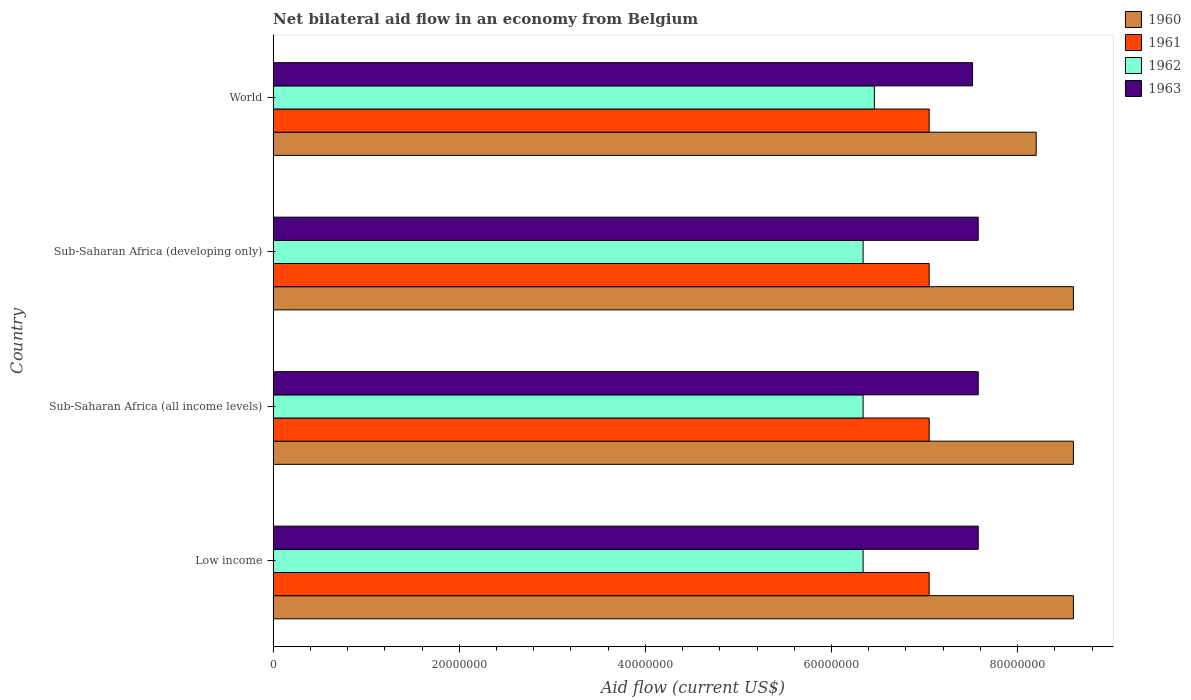How many different coloured bars are there?
Your response must be concise. 4. Are the number of bars per tick equal to the number of legend labels?
Give a very brief answer. Yes. Are the number of bars on each tick of the Y-axis equal?
Offer a terse response. Yes. How many bars are there on the 2nd tick from the top?
Provide a succinct answer. 4. How many bars are there on the 4th tick from the bottom?
Provide a succinct answer. 4. What is the label of the 3rd group of bars from the top?
Your response must be concise. Sub-Saharan Africa (all income levels). What is the net bilateral aid flow in 1961 in Low income?
Ensure brevity in your answer.  7.05e+07. Across all countries, what is the maximum net bilateral aid flow in 1962?
Provide a short and direct response. 6.46e+07. Across all countries, what is the minimum net bilateral aid flow in 1963?
Your response must be concise. 7.52e+07. In which country was the net bilateral aid flow in 1962 minimum?
Your response must be concise. Low income. What is the total net bilateral aid flow in 1960 in the graph?
Keep it short and to the point. 3.40e+08. What is the difference between the net bilateral aid flow in 1961 in Sub-Saharan Africa (developing only) and that in World?
Make the answer very short. 0. What is the difference between the net bilateral aid flow in 1960 in World and the net bilateral aid flow in 1963 in Low income?
Provide a short and direct response. 6.23e+06. What is the average net bilateral aid flow in 1961 per country?
Offer a very short reply. 7.05e+07. What is the difference between the net bilateral aid flow in 1962 and net bilateral aid flow in 1961 in Sub-Saharan Africa (all income levels)?
Make the answer very short. -7.10e+06. In how many countries, is the net bilateral aid flow in 1960 greater than 32000000 US$?
Keep it short and to the point. 4. What is the ratio of the net bilateral aid flow in 1963 in Sub-Saharan Africa (all income levels) to that in World?
Your answer should be very brief. 1.01. Is the net bilateral aid flow in 1963 in Sub-Saharan Africa (all income levels) less than that in Sub-Saharan Africa (developing only)?
Your answer should be compact. No. Is the difference between the net bilateral aid flow in 1962 in Low income and World greater than the difference between the net bilateral aid flow in 1961 in Low income and World?
Offer a very short reply. No. What is the difference between the highest and the second highest net bilateral aid flow in 1962?
Your response must be concise. 1.21e+06. What is the difference between the highest and the lowest net bilateral aid flow in 1962?
Your answer should be very brief. 1.21e+06. In how many countries, is the net bilateral aid flow in 1962 greater than the average net bilateral aid flow in 1962 taken over all countries?
Make the answer very short. 1. Is the sum of the net bilateral aid flow in 1961 in Sub-Saharan Africa (all income levels) and World greater than the maximum net bilateral aid flow in 1960 across all countries?
Your answer should be compact. Yes. Is it the case that in every country, the sum of the net bilateral aid flow in 1960 and net bilateral aid flow in 1963 is greater than the net bilateral aid flow in 1961?
Provide a short and direct response. Yes. What is the difference between two consecutive major ticks on the X-axis?
Offer a very short reply. 2.00e+07. Are the values on the major ticks of X-axis written in scientific E-notation?
Make the answer very short. No. Does the graph contain any zero values?
Ensure brevity in your answer.  No. What is the title of the graph?
Provide a short and direct response. Net bilateral aid flow in an economy from Belgium. Does "1967" appear as one of the legend labels in the graph?
Offer a very short reply. No. What is the label or title of the X-axis?
Keep it short and to the point. Aid flow (current US$). What is the label or title of the Y-axis?
Offer a terse response. Country. What is the Aid flow (current US$) in 1960 in Low income?
Make the answer very short. 8.60e+07. What is the Aid flow (current US$) of 1961 in Low income?
Give a very brief answer. 7.05e+07. What is the Aid flow (current US$) of 1962 in Low income?
Your response must be concise. 6.34e+07. What is the Aid flow (current US$) of 1963 in Low income?
Your response must be concise. 7.58e+07. What is the Aid flow (current US$) in 1960 in Sub-Saharan Africa (all income levels)?
Provide a short and direct response. 8.60e+07. What is the Aid flow (current US$) in 1961 in Sub-Saharan Africa (all income levels)?
Offer a very short reply. 7.05e+07. What is the Aid flow (current US$) of 1962 in Sub-Saharan Africa (all income levels)?
Keep it short and to the point. 6.34e+07. What is the Aid flow (current US$) in 1963 in Sub-Saharan Africa (all income levels)?
Provide a succinct answer. 7.58e+07. What is the Aid flow (current US$) in 1960 in Sub-Saharan Africa (developing only)?
Keep it short and to the point. 8.60e+07. What is the Aid flow (current US$) of 1961 in Sub-Saharan Africa (developing only)?
Offer a terse response. 7.05e+07. What is the Aid flow (current US$) of 1962 in Sub-Saharan Africa (developing only)?
Keep it short and to the point. 6.34e+07. What is the Aid flow (current US$) of 1963 in Sub-Saharan Africa (developing only)?
Keep it short and to the point. 7.58e+07. What is the Aid flow (current US$) of 1960 in World?
Your answer should be very brief. 8.20e+07. What is the Aid flow (current US$) in 1961 in World?
Your answer should be compact. 7.05e+07. What is the Aid flow (current US$) in 1962 in World?
Keep it short and to the point. 6.46e+07. What is the Aid flow (current US$) in 1963 in World?
Your answer should be compact. 7.52e+07. Across all countries, what is the maximum Aid flow (current US$) in 1960?
Provide a succinct answer. 8.60e+07. Across all countries, what is the maximum Aid flow (current US$) in 1961?
Make the answer very short. 7.05e+07. Across all countries, what is the maximum Aid flow (current US$) in 1962?
Give a very brief answer. 6.46e+07. Across all countries, what is the maximum Aid flow (current US$) in 1963?
Your response must be concise. 7.58e+07. Across all countries, what is the minimum Aid flow (current US$) of 1960?
Give a very brief answer. 8.20e+07. Across all countries, what is the minimum Aid flow (current US$) of 1961?
Keep it short and to the point. 7.05e+07. Across all countries, what is the minimum Aid flow (current US$) of 1962?
Keep it short and to the point. 6.34e+07. Across all countries, what is the minimum Aid flow (current US$) in 1963?
Your answer should be very brief. 7.52e+07. What is the total Aid flow (current US$) in 1960 in the graph?
Make the answer very short. 3.40e+08. What is the total Aid flow (current US$) of 1961 in the graph?
Your response must be concise. 2.82e+08. What is the total Aid flow (current US$) in 1962 in the graph?
Ensure brevity in your answer.  2.55e+08. What is the total Aid flow (current US$) of 1963 in the graph?
Your answer should be very brief. 3.02e+08. What is the difference between the Aid flow (current US$) of 1960 in Low income and that in Sub-Saharan Africa (all income levels)?
Keep it short and to the point. 0. What is the difference between the Aid flow (current US$) in 1962 in Low income and that in Sub-Saharan Africa (all income levels)?
Ensure brevity in your answer.  0. What is the difference between the Aid flow (current US$) of 1963 in Low income and that in Sub-Saharan Africa (all income levels)?
Your response must be concise. 0. What is the difference between the Aid flow (current US$) of 1961 in Low income and that in Sub-Saharan Africa (developing only)?
Make the answer very short. 0. What is the difference between the Aid flow (current US$) in 1960 in Low income and that in World?
Provide a succinct answer. 4.00e+06. What is the difference between the Aid flow (current US$) in 1962 in Low income and that in World?
Ensure brevity in your answer.  -1.21e+06. What is the difference between the Aid flow (current US$) of 1960 in Sub-Saharan Africa (all income levels) and that in Sub-Saharan Africa (developing only)?
Your answer should be very brief. 0. What is the difference between the Aid flow (current US$) in 1960 in Sub-Saharan Africa (all income levels) and that in World?
Provide a short and direct response. 4.00e+06. What is the difference between the Aid flow (current US$) in 1961 in Sub-Saharan Africa (all income levels) and that in World?
Ensure brevity in your answer.  0. What is the difference between the Aid flow (current US$) in 1962 in Sub-Saharan Africa (all income levels) and that in World?
Provide a short and direct response. -1.21e+06. What is the difference between the Aid flow (current US$) of 1960 in Sub-Saharan Africa (developing only) and that in World?
Provide a succinct answer. 4.00e+06. What is the difference between the Aid flow (current US$) in 1962 in Sub-Saharan Africa (developing only) and that in World?
Provide a short and direct response. -1.21e+06. What is the difference between the Aid flow (current US$) of 1963 in Sub-Saharan Africa (developing only) and that in World?
Your answer should be compact. 6.10e+05. What is the difference between the Aid flow (current US$) in 1960 in Low income and the Aid flow (current US$) in 1961 in Sub-Saharan Africa (all income levels)?
Your response must be concise. 1.55e+07. What is the difference between the Aid flow (current US$) of 1960 in Low income and the Aid flow (current US$) of 1962 in Sub-Saharan Africa (all income levels)?
Provide a succinct answer. 2.26e+07. What is the difference between the Aid flow (current US$) in 1960 in Low income and the Aid flow (current US$) in 1963 in Sub-Saharan Africa (all income levels)?
Offer a very short reply. 1.02e+07. What is the difference between the Aid flow (current US$) in 1961 in Low income and the Aid flow (current US$) in 1962 in Sub-Saharan Africa (all income levels)?
Provide a succinct answer. 7.10e+06. What is the difference between the Aid flow (current US$) of 1961 in Low income and the Aid flow (current US$) of 1963 in Sub-Saharan Africa (all income levels)?
Give a very brief answer. -5.27e+06. What is the difference between the Aid flow (current US$) in 1962 in Low income and the Aid flow (current US$) in 1963 in Sub-Saharan Africa (all income levels)?
Ensure brevity in your answer.  -1.24e+07. What is the difference between the Aid flow (current US$) in 1960 in Low income and the Aid flow (current US$) in 1961 in Sub-Saharan Africa (developing only)?
Provide a succinct answer. 1.55e+07. What is the difference between the Aid flow (current US$) in 1960 in Low income and the Aid flow (current US$) in 1962 in Sub-Saharan Africa (developing only)?
Keep it short and to the point. 2.26e+07. What is the difference between the Aid flow (current US$) in 1960 in Low income and the Aid flow (current US$) in 1963 in Sub-Saharan Africa (developing only)?
Give a very brief answer. 1.02e+07. What is the difference between the Aid flow (current US$) of 1961 in Low income and the Aid flow (current US$) of 1962 in Sub-Saharan Africa (developing only)?
Make the answer very short. 7.10e+06. What is the difference between the Aid flow (current US$) in 1961 in Low income and the Aid flow (current US$) in 1963 in Sub-Saharan Africa (developing only)?
Provide a short and direct response. -5.27e+06. What is the difference between the Aid flow (current US$) in 1962 in Low income and the Aid flow (current US$) in 1963 in Sub-Saharan Africa (developing only)?
Your answer should be compact. -1.24e+07. What is the difference between the Aid flow (current US$) in 1960 in Low income and the Aid flow (current US$) in 1961 in World?
Provide a succinct answer. 1.55e+07. What is the difference between the Aid flow (current US$) in 1960 in Low income and the Aid flow (current US$) in 1962 in World?
Your response must be concise. 2.14e+07. What is the difference between the Aid flow (current US$) of 1960 in Low income and the Aid flow (current US$) of 1963 in World?
Keep it short and to the point. 1.08e+07. What is the difference between the Aid flow (current US$) in 1961 in Low income and the Aid flow (current US$) in 1962 in World?
Your response must be concise. 5.89e+06. What is the difference between the Aid flow (current US$) of 1961 in Low income and the Aid flow (current US$) of 1963 in World?
Offer a terse response. -4.66e+06. What is the difference between the Aid flow (current US$) in 1962 in Low income and the Aid flow (current US$) in 1963 in World?
Offer a terse response. -1.18e+07. What is the difference between the Aid flow (current US$) in 1960 in Sub-Saharan Africa (all income levels) and the Aid flow (current US$) in 1961 in Sub-Saharan Africa (developing only)?
Your answer should be very brief. 1.55e+07. What is the difference between the Aid flow (current US$) of 1960 in Sub-Saharan Africa (all income levels) and the Aid flow (current US$) of 1962 in Sub-Saharan Africa (developing only)?
Your answer should be very brief. 2.26e+07. What is the difference between the Aid flow (current US$) of 1960 in Sub-Saharan Africa (all income levels) and the Aid flow (current US$) of 1963 in Sub-Saharan Africa (developing only)?
Offer a very short reply. 1.02e+07. What is the difference between the Aid flow (current US$) in 1961 in Sub-Saharan Africa (all income levels) and the Aid flow (current US$) in 1962 in Sub-Saharan Africa (developing only)?
Give a very brief answer. 7.10e+06. What is the difference between the Aid flow (current US$) of 1961 in Sub-Saharan Africa (all income levels) and the Aid flow (current US$) of 1963 in Sub-Saharan Africa (developing only)?
Keep it short and to the point. -5.27e+06. What is the difference between the Aid flow (current US$) of 1962 in Sub-Saharan Africa (all income levels) and the Aid flow (current US$) of 1963 in Sub-Saharan Africa (developing only)?
Keep it short and to the point. -1.24e+07. What is the difference between the Aid flow (current US$) in 1960 in Sub-Saharan Africa (all income levels) and the Aid flow (current US$) in 1961 in World?
Offer a terse response. 1.55e+07. What is the difference between the Aid flow (current US$) of 1960 in Sub-Saharan Africa (all income levels) and the Aid flow (current US$) of 1962 in World?
Offer a very short reply. 2.14e+07. What is the difference between the Aid flow (current US$) in 1960 in Sub-Saharan Africa (all income levels) and the Aid flow (current US$) in 1963 in World?
Ensure brevity in your answer.  1.08e+07. What is the difference between the Aid flow (current US$) in 1961 in Sub-Saharan Africa (all income levels) and the Aid flow (current US$) in 1962 in World?
Keep it short and to the point. 5.89e+06. What is the difference between the Aid flow (current US$) in 1961 in Sub-Saharan Africa (all income levels) and the Aid flow (current US$) in 1963 in World?
Provide a succinct answer. -4.66e+06. What is the difference between the Aid flow (current US$) of 1962 in Sub-Saharan Africa (all income levels) and the Aid flow (current US$) of 1963 in World?
Ensure brevity in your answer.  -1.18e+07. What is the difference between the Aid flow (current US$) of 1960 in Sub-Saharan Africa (developing only) and the Aid flow (current US$) of 1961 in World?
Give a very brief answer. 1.55e+07. What is the difference between the Aid flow (current US$) in 1960 in Sub-Saharan Africa (developing only) and the Aid flow (current US$) in 1962 in World?
Provide a short and direct response. 2.14e+07. What is the difference between the Aid flow (current US$) in 1960 in Sub-Saharan Africa (developing only) and the Aid flow (current US$) in 1963 in World?
Keep it short and to the point. 1.08e+07. What is the difference between the Aid flow (current US$) of 1961 in Sub-Saharan Africa (developing only) and the Aid flow (current US$) of 1962 in World?
Make the answer very short. 5.89e+06. What is the difference between the Aid flow (current US$) in 1961 in Sub-Saharan Africa (developing only) and the Aid flow (current US$) in 1963 in World?
Your answer should be very brief. -4.66e+06. What is the difference between the Aid flow (current US$) of 1962 in Sub-Saharan Africa (developing only) and the Aid flow (current US$) of 1963 in World?
Your response must be concise. -1.18e+07. What is the average Aid flow (current US$) of 1960 per country?
Ensure brevity in your answer.  8.50e+07. What is the average Aid flow (current US$) of 1961 per country?
Give a very brief answer. 7.05e+07. What is the average Aid flow (current US$) in 1962 per country?
Make the answer very short. 6.37e+07. What is the average Aid flow (current US$) in 1963 per country?
Your answer should be very brief. 7.56e+07. What is the difference between the Aid flow (current US$) in 1960 and Aid flow (current US$) in 1961 in Low income?
Offer a terse response. 1.55e+07. What is the difference between the Aid flow (current US$) in 1960 and Aid flow (current US$) in 1962 in Low income?
Keep it short and to the point. 2.26e+07. What is the difference between the Aid flow (current US$) of 1960 and Aid flow (current US$) of 1963 in Low income?
Keep it short and to the point. 1.02e+07. What is the difference between the Aid flow (current US$) of 1961 and Aid flow (current US$) of 1962 in Low income?
Provide a short and direct response. 7.10e+06. What is the difference between the Aid flow (current US$) of 1961 and Aid flow (current US$) of 1963 in Low income?
Offer a terse response. -5.27e+06. What is the difference between the Aid flow (current US$) in 1962 and Aid flow (current US$) in 1963 in Low income?
Offer a very short reply. -1.24e+07. What is the difference between the Aid flow (current US$) in 1960 and Aid flow (current US$) in 1961 in Sub-Saharan Africa (all income levels)?
Provide a succinct answer. 1.55e+07. What is the difference between the Aid flow (current US$) in 1960 and Aid flow (current US$) in 1962 in Sub-Saharan Africa (all income levels)?
Provide a succinct answer. 2.26e+07. What is the difference between the Aid flow (current US$) in 1960 and Aid flow (current US$) in 1963 in Sub-Saharan Africa (all income levels)?
Provide a short and direct response. 1.02e+07. What is the difference between the Aid flow (current US$) in 1961 and Aid flow (current US$) in 1962 in Sub-Saharan Africa (all income levels)?
Make the answer very short. 7.10e+06. What is the difference between the Aid flow (current US$) in 1961 and Aid flow (current US$) in 1963 in Sub-Saharan Africa (all income levels)?
Provide a succinct answer. -5.27e+06. What is the difference between the Aid flow (current US$) in 1962 and Aid flow (current US$) in 1963 in Sub-Saharan Africa (all income levels)?
Your response must be concise. -1.24e+07. What is the difference between the Aid flow (current US$) in 1960 and Aid flow (current US$) in 1961 in Sub-Saharan Africa (developing only)?
Your answer should be very brief. 1.55e+07. What is the difference between the Aid flow (current US$) of 1960 and Aid flow (current US$) of 1962 in Sub-Saharan Africa (developing only)?
Offer a terse response. 2.26e+07. What is the difference between the Aid flow (current US$) of 1960 and Aid flow (current US$) of 1963 in Sub-Saharan Africa (developing only)?
Give a very brief answer. 1.02e+07. What is the difference between the Aid flow (current US$) of 1961 and Aid flow (current US$) of 1962 in Sub-Saharan Africa (developing only)?
Provide a succinct answer. 7.10e+06. What is the difference between the Aid flow (current US$) in 1961 and Aid flow (current US$) in 1963 in Sub-Saharan Africa (developing only)?
Provide a short and direct response. -5.27e+06. What is the difference between the Aid flow (current US$) of 1962 and Aid flow (current US$) of 1963 in Sub-Saharan Africa (developing only)?
Keep it short and to the point. -1.24e+07. What is the difference between the Aid flow (current US$) of 1960 and Aid flow (current US$) of 1961 in World?
Offer a very short reply. 1.15e+07. What is the difference between the Aid flow (current US$) in 1960 and Aid flow (current US$) in 1962 in World?
Your response must be concise. 1.74e+07. What is the difference between the Aid flow (current US$) of 1960 and Aid flow (current US$) of 1963 in World?
Your answer should be compact. 6.84e+06. What is the difference between the Aid flow (current US$) in 1961 and Aid flow (current US$) in 1962 in World?
Offer a terse response. 5.89e+06. What is the difference between the Aid flow (current US$) in 1961 and Aid flow (current US$) in 1963 in World?
Provide a succinct answer. -4.66e+06. What is the difference between the Aid flow (current US$) of 1962 and Aid flow (current US$) of 1963 in World?
Give a very brief answer. -1.06e+07. What is the ratio of the Aid flow (current US$) in 1960 in Low income to that in Sub-Saharan Africa (all income levels)?
Provide a succinct answer. 1. What is the ratio of the Aid flow (current US$) of 1962 in Low income to that in Sub-Saharan Africa (all income levels)?
Keep it short and to the point. 1. What is the ratio of the Aid flow (current US$) of 1963 in Low income to that in Sub-Saharan Africa (all income levels)?
Your response must be concise. 1. What is the ratio of the Aid flow (current US$) of 1960 in Low income to that in Sub-Saharan Africa (developing only)?
Give a very brief answer. 1. What is the ratio of the Aid flow (current US$) of 1962 in Low income to that in Sub-Saharan Africa (developing only)?
Your response must be concise. 1. What is the ratio of the Aid flow (current US$) in 1963 in Low income to that in Sub-Saharan Africa (developing only)?
Offer a terse response. 1. What is the ratio of the Aid flow (current US$) of 1960 in Low income to that in World?
Make the answer very short. 1.05. What is the ratio of the Aid flow (current US$) of 1961 in Low income to that in World?
Your answer should be compact. 1. What is the ratio of the Aid flow (current US$) in 1962 in Low income to that in World?
Keep it short and to the point. 0.98. What is the ratio of the Aid flow (current US$) in 1960 in Sub-Saharan Africa (all income levels) to that in Sub-Saharan Africa (developing only)?
Give a very brief answer. 1. What is the ratio of the Aid flow (current US$) in 1961 in Sub-Saharan Africa (all income levels) to that in Sub-Saharan Africa (developing only)?
Offer a very short reply. 1. What is the ratio of the Aid flow (current US$) of 1963 in Sub-Saharan Africa (all income levels) to that in Sub-Saharan Africa (developing only)?
Your answer should be compact. 1. What is the ratio of the Aid flow (current US$) of 1960 in Sub-Saharan Africa (all income levels) to that in World?
Make the answer very short. 1.05. What is the ratio of the Aid flow (current US$) of 1961 in Sub-Saharan Africa (all income levels) to that in World?
Your answer should be compact. 1. What is the ratio of the Aid flow (current US$) in 1962 in Sub-Saharan Africa (all income levels) to that in World?
Provide a short and direct response. 0.98. What is the ratio of the Aid flow (current US$) of 1960 in Sub-Saharan Africa (developing only) to that in World?
Ensure brevity in your answer.  1.05. What is the ratio of the Aid flow (current US$) of 1962 in Sub-Saharan Africa (developing only) to that in World?
Ensure brevity in your answer.  0.98. What is the difference between the highest and the second highest Aid flow (current US$) in 1962?
Your response must be concise. 1.21e+06. What is the difference between the highest and the second highest Aid flow (current US$) of 1963?
Keep it short and to the point. 0. What is the difference between the highest and the lowest Aid flow (current US$) in 1960?
Provide a succinct answer. 4.00e+06. What is the difference between the highest and the lowest Aid flow (current US$) of 1962?
Offer a terse response. 1.21e+06. 